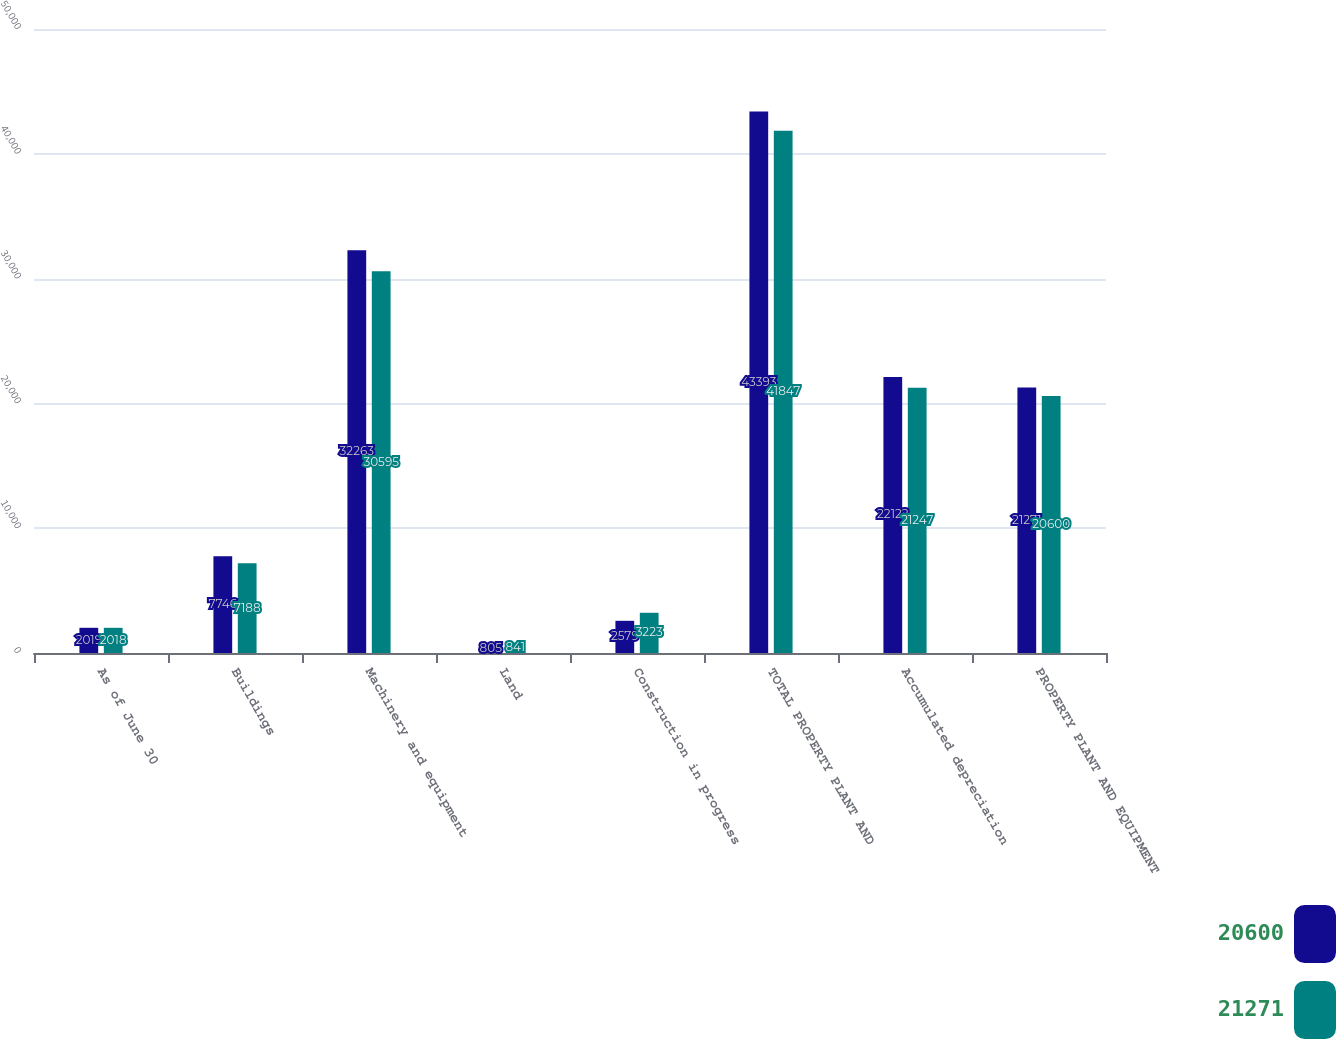<chart> <loc_0><loc_0><loc_500><loc_500><stacked_bar_chart><ecel><fcel>As of June 30<fcel>Buildings<fcel>Machinery and equipment<fcel>Land<fcel>Construction in progress<fcel>TOTAL PROPERTY PLANT AND<fcel>Accumulated depreciation<fcel>PROPERTY PLANT AND EQUIPMENT<nl><fcel>20600<fcel>2019<fcel>7746<fcel>32263<fcel>805<fcel>2579<fcel>43393<fcel>22122<fcel>21271<nl><fcel>21271<fcel>2018<fcel>7188<fcel>30595<fcel>841<fcel>3223<fcel>41847<fcel>21247<fcel>20600<nl></chart> 